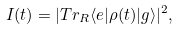Convert formula to latex. <formula><loc_0><loc_0><loc_500><loc_500>I ( t ) = | T r _ { R } \langle e | \rho ( t ) | g \rangle | ^ { 2 } ,</formula> 